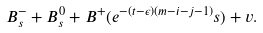Convert formula to latex. <formula><loc_0><loc_0><loc_500><loc_500>B _ { s } ^ { - } + B _ { s } ^ { 0 } + B ^ { + } ( e ^ { - ( t - \epsilon ) ( m - i - j - 1 ) } s ) + v .</formula> 